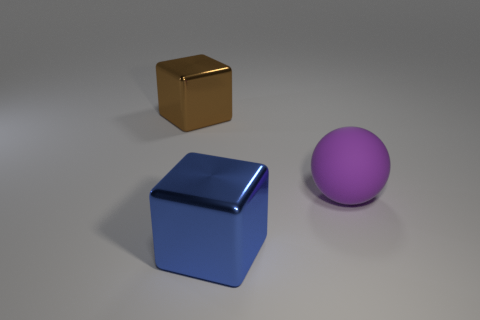Add 3 blue cubes. How many objects exist? 6 Subtract all cubes. How many objects are left? 1 Add 2 big shiny objects. How many big shiny objects are left? 4 Add 2 purple metal balls. How many purple metal balls exist? 2 Subtract 0 gray cubes. How many objects are left? 3 Subtract all purple balls. Subtract all blue blocks. How many objects are left? 1 